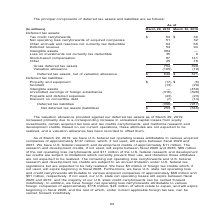According to Nortonlifelock's financial document, What does the table show? The principal components of deferred tax assets and liabilities. The document states: "The principal components of deferred tax assets and liabilities are as follows:..." Also, As of March 30, 2018, what is the  Tax credit carryforwards? According to the financial document, $30 (in millions). The relevant text states: "As of (In millions) March 29, 2019 March 30, 2018..." Also, What is the reason for the increase in valuation allowance provided against deferred tax assets as of March 29, 2019? due to a corresponding increase in unrealized capital losses from equity investments, certain acquired tax loss and tax credits carryforwards, and California research and development credits. The document states: "assets as of March 29, 2019, increased primarily due to a corresponding increase in unrealized capital losses from equity investments, certain acquire..." Also, can you calculate: What is the total Net deferred tax assets (liabilities) for as of  March 29, 2019 and March 30, 2018? Based on the calculation: 253+(-546), the result is -293 (in millions). This is based on the information: "Net deferred tax assets (liabilities) $ 253 $ (546) Net deferred tax assets (liabilities) $ 253 $ (546)..." The key data points involved are: 253, 546. Also, can you calculate: What is the average Net deferred tax assets (liabilities) for as of  March 29, 2019 and  March 30, 2018? To answer this question, I need to perform calculations using the financial data. The calculation is: (253+(-546))/2, which equals -146.5 (in millions). This is based on the information: "Net deferred tax assets (liabilities) $ 253 $ (546) Net deferred tax assets (liabilities) $ 253 $ (546) Net deferred tax assets (liabilities) $ 253 $ (546)..." The key data points involved are: 2, 253, 546. Also, can you calculate: As of March 29, 2019, What is Intangible assets expressed as a percentage of  Gross deferred tax assets? Based on the calculation: 384/754, the result is 50.93 (percentage). This is based on the information: "Gross deferred tax assets 754 390 Valuation allowance (105) (19) le 64 66 Deferred revenue 54 94 Intangible assets 384 — Loss on investments not currently tax deductible 35 9 Stock-based compensation ..." The key data points involved are: 384, 754. 